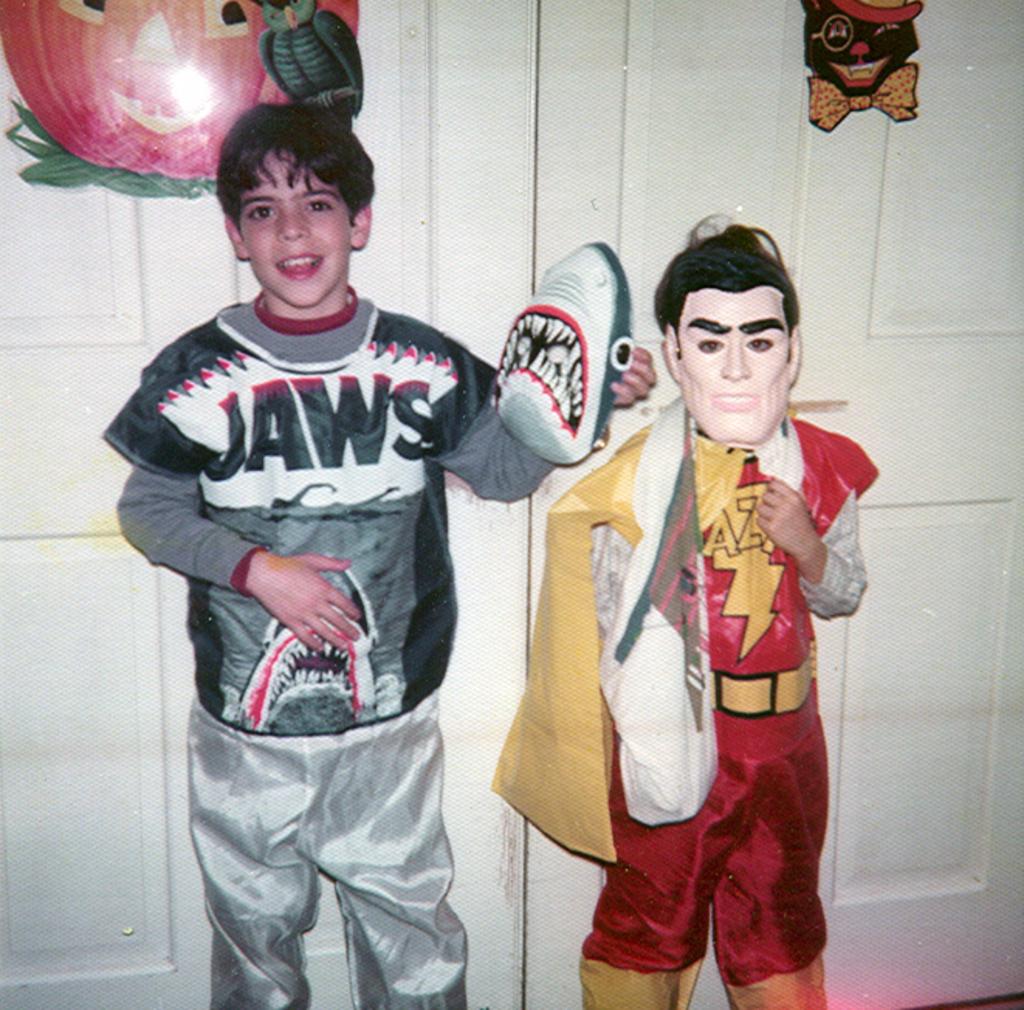What letters can you see on the red outfit?
Keep it short and to the point. Az. 